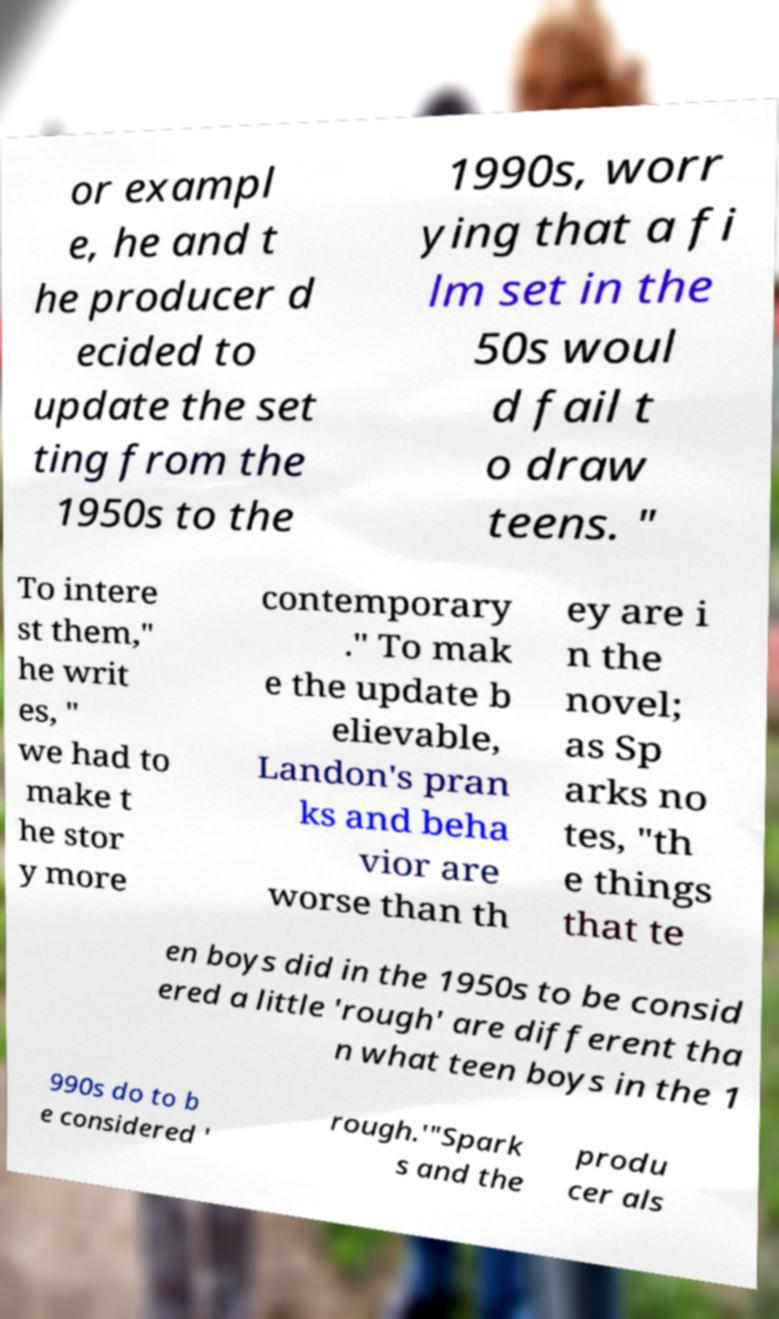Could you extract and type out the text from this image? or exampl e, he and t he producer d ecided to update the set ting from the 1950s to the 1990s, worr ying that a fi lm set in the 50s woul d fail t o draw teens. " To intere st them," he writ es, " we had to make t he stor y more contemporary ." To mak e the update b elievable, Landon's pran ks and beha vior are worse than th ey are i n the novel; as Sp arks no tes, "th e things that te en boys did in the 1950s to be consid ered a little 'rough' are different tha n what teen boys in the 1 990s do to b e considered ' rough.'"Spark s and the produ cer als 